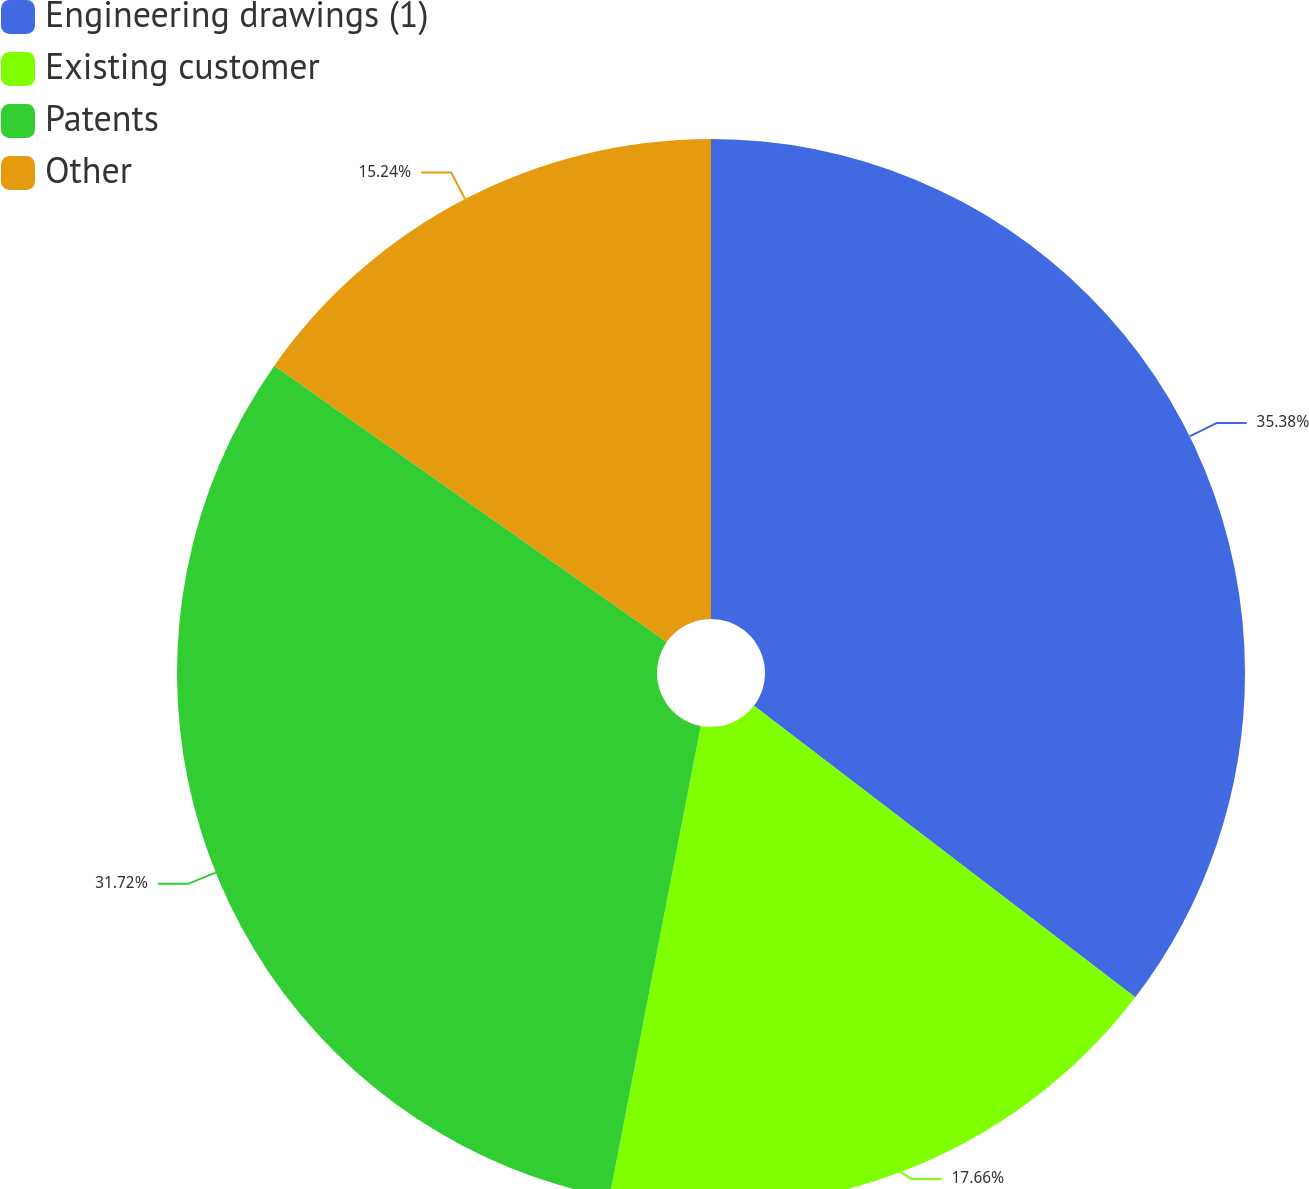<chart> <loc_0><loc_0><loc_500><loc_500><pie_chart><fcel>Engineering drawings (1)<fcel>Existing customer<fcel>Patents<fcel>Other<nl><fcel>35.39%<fcel>17.66%<fcel>31.72%<fcel>15.24%<nl></chart> 